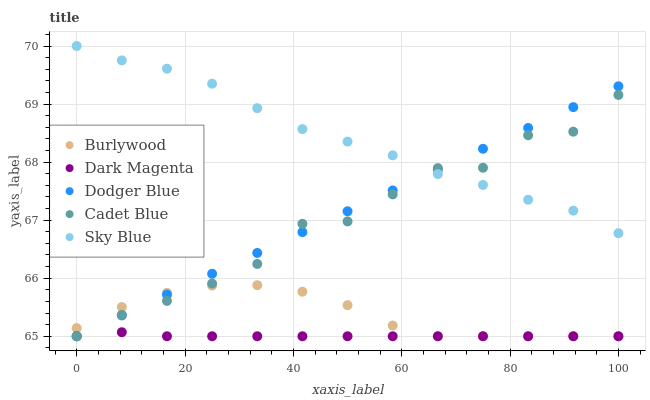Does Dark Magenta have the minimum area under the curve?
Answer yes or no. Yes. Does Sky Blue have the maximum area under the curve?
Answer yes or no. Yes. Does Cadet Blue have the minimum area under the curve?
Answer yes or no. No. Does Cadet Blue have the maximum area under the curve?
Answer yes or no. No. Is Dodger Blue the smoothest?
Answer yes or no. Yes. Is Cadet Blue the roughest?
Answer yes or no. Yes. Is Sky Blue the smoothest?
Answer yes or no. No. Is Sky Blue the roughest?
Answer yes or no. No. Does Burlywood have the lowest value?
Answer yes or no. Yes. Does Sky Blue have the lowest value?
Answer yes or no. No. Does Sky Blue have the highest value?
Answer yes or no. Yes. Does Cadet Blue have the highest value?
Answer yes or no. No. Is Dark Magenta less than Sky Blue?
Answer yes or no. Yes. Is Sky Blue greater than Dark Magenta?
Answer yes or no. Yes. Does Dark Magenta intersect Dodger Blue?
Answer yes or no. Yes. Is Dark Magenta less than Dodger Blue?
Answer yes or no. No. Is Dark Magenta greater than Dodger Blue?
Answer yes or no. No. Does Dark Magenta intersect Sky Blue?
Answer yes or no. No. 